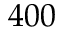<formula> <loc_0><loc_0><loc_500><loc_500>4 0 0</formula> 